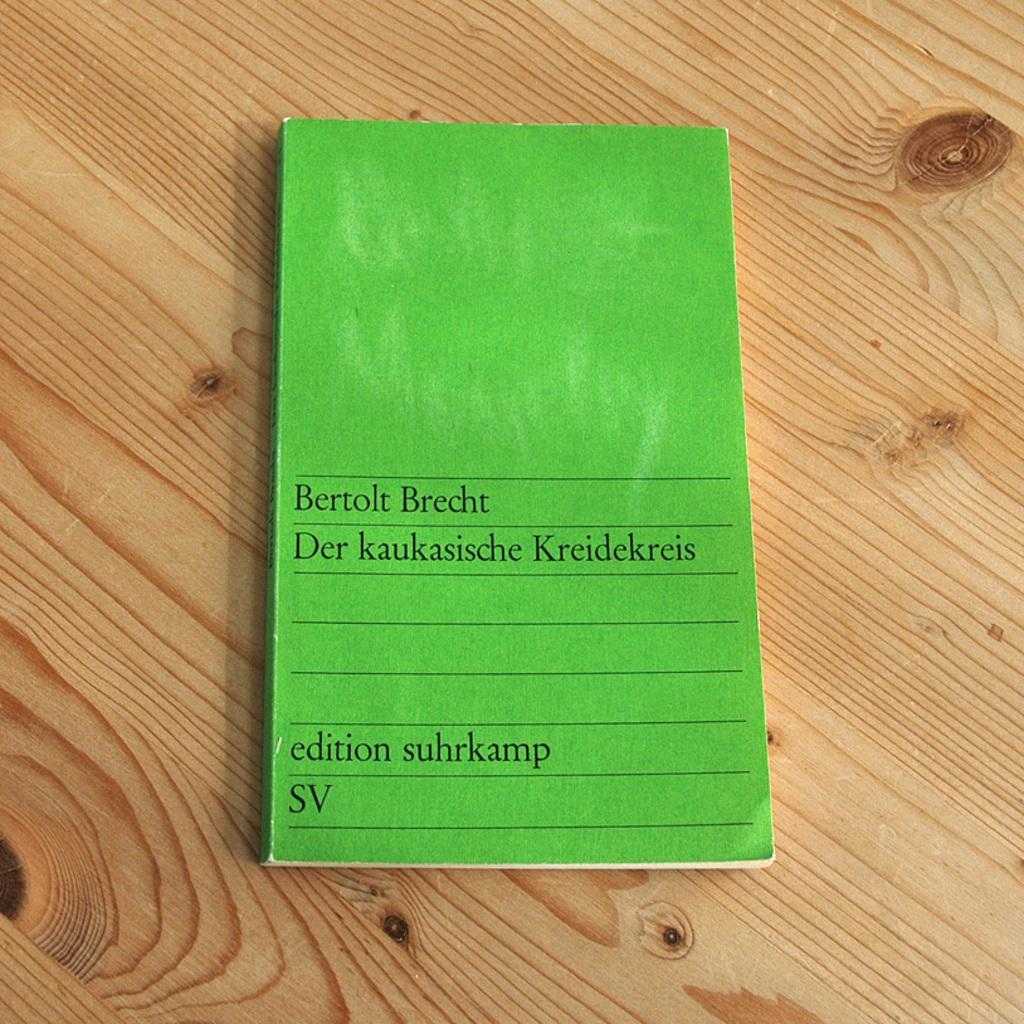Provide a one-sentence caption for the provided image. A Bertolt Brecht book, "Der kaukasische Kreidekreis", on a brown wood table. 